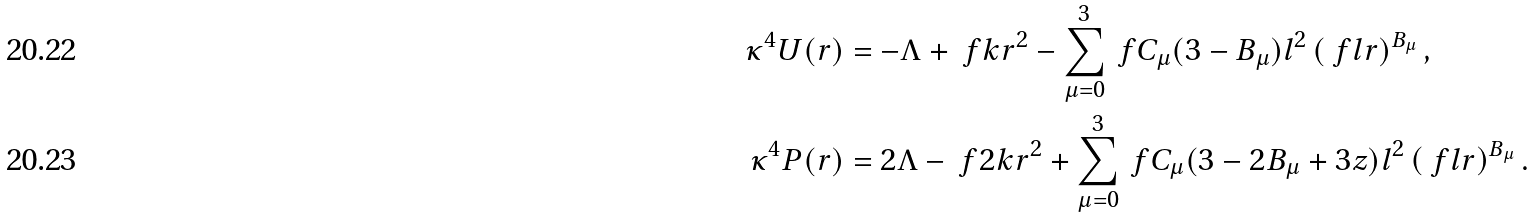<formula> <loc_0><loc_0><loc_500><loc_500>\kappa ^ { 4 } U ( r ) & = - \Lambda + \ f { k } { r ^ { 2 } } - \sum _ { \mu = 0 } ^ { 3 } \ f { C _ { \mu } ( 3 - B _ { \mu } ) } { l ^ { 2 } } \left ( \ f { l } { r } \right ) ^ { B _ { \mu } } , \\ \kappa ^ { 4 } P ( r ) & = 2 \Lambda - \ f { 2 k } { r ^ { 2 } } + \sum _ { \mu = 0 } ^ { 3 } \ f { C _ { \mu } ( 3 - 2 B _ { \mu } + 3 z ) } { l ^ { 2 } } \left ( \ f { l } { r } \right ) ^ { B _ { \mu } } .</formula> 